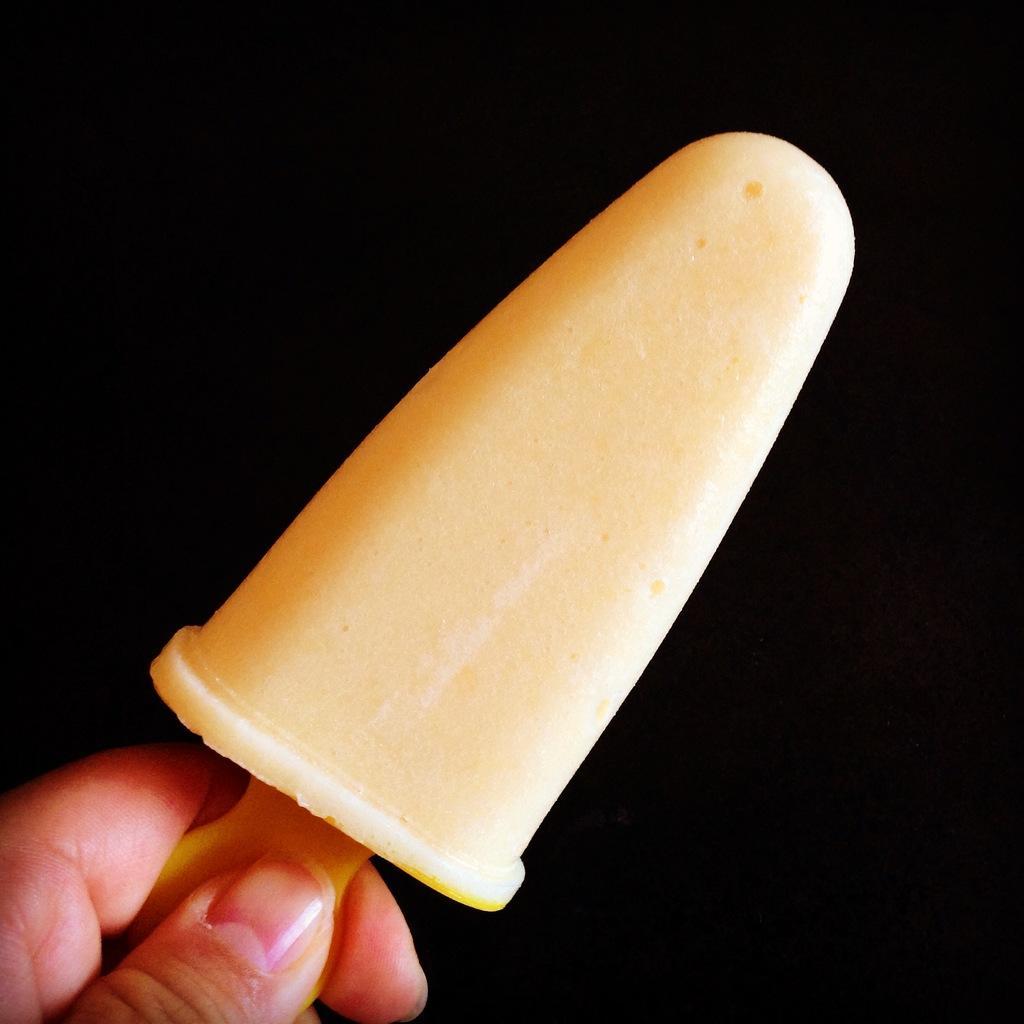Can you describe this image briefly? In this image we can see a person's hand. A person is holding an ice cream in the image. 